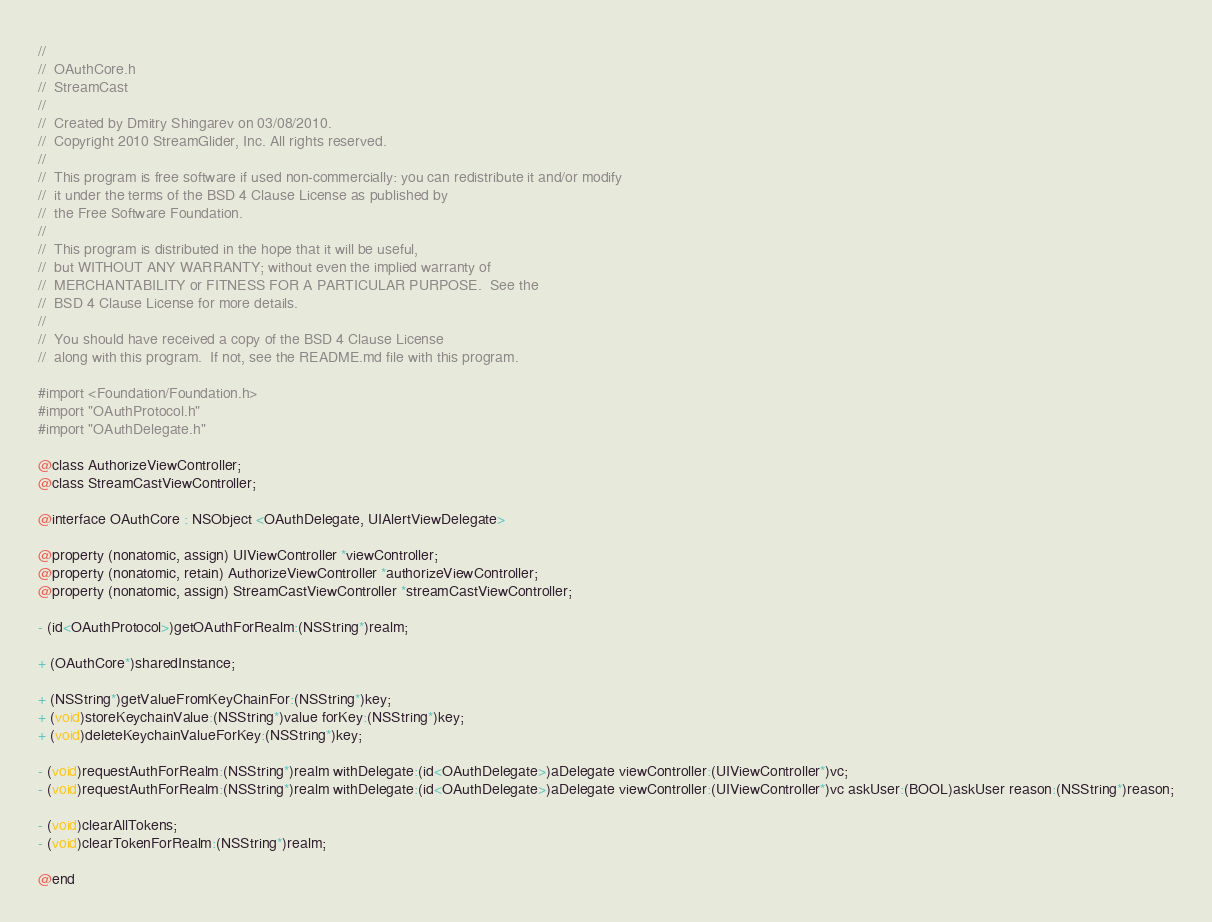<code> <loc_0><loc_0><loc_500><loc_500><_C_>//
//  OAuthCore.h
//  StreamCast
//
//  Created by Dmitry Shingarev on 03/08/2010.
//  Copyright 2010 StreamGlider, Inc. All rights reserved.
//
//  This program is free software if used non-commercially: you can redistribute it and/or modify
//  it under the terms of the BSD 4 Clause License as published by
//  the Free Software Foundation.
//
//  This program is distributed in the hope that it will be useful,
//  but WITHOUT ANY WARRANTY; without even the implied warranty of
//  MERCHANTABILITY or FITNESS FOR A PARTICULAR PURPOSE.  See the
//  BSD 4 Clause License for more details.
//
//  You should have received a copy of the BSD 4 Clause License
//  along with this program.  If not, see the README.md file with this program.

#import <Foundation/Foundation.h>
#import "OAuthProtocol.h"
#import "OAuthDelegate.h"

@class AuthorizeViewController;
@class StreamCastViewController;

@interface OAuthCore : NSObject <OAuthDelegate, UIAlertViewDelegate> 
	
@property (nonatomic, assign) UIViewController *viewController;
@property (nonatomic, retain) AuthorizeViewController *authorizeViewController;
@property (nonatomic, assign) StreamCastViewController *streamCastViewController;

- (id<OAuthProtocol>)getOAuthForRealm:(NSString*)realm;

+ (OAuthCore*)sharedInstance;

+ (NSString*)getValueFromKeyChainFor:(NSString*)key;
+ (void)storeKeychainValue:(NSString*)value forKey:(NSString*)key;  
+ (void)deleteKeychainValueForKey:(NSString*)key;

- (void)requestAuthForRealm:(NSString*)realm withDelegate:(id<OAuthDelegate>)aDelegate viewController:(UIViewController*)vc;
- (void)requestAuthForRealm:(NSString*)realm withDelegate:(id<OAuthDelegate>)aDelegate viewController:(UIViewController*)vc askUser:(BOOL)askUser reason:(NSString*)reason;

- (void)clearAllTokens;
- (void)clearTokenForRealm:(NSString*)realm;

@end
</code> 